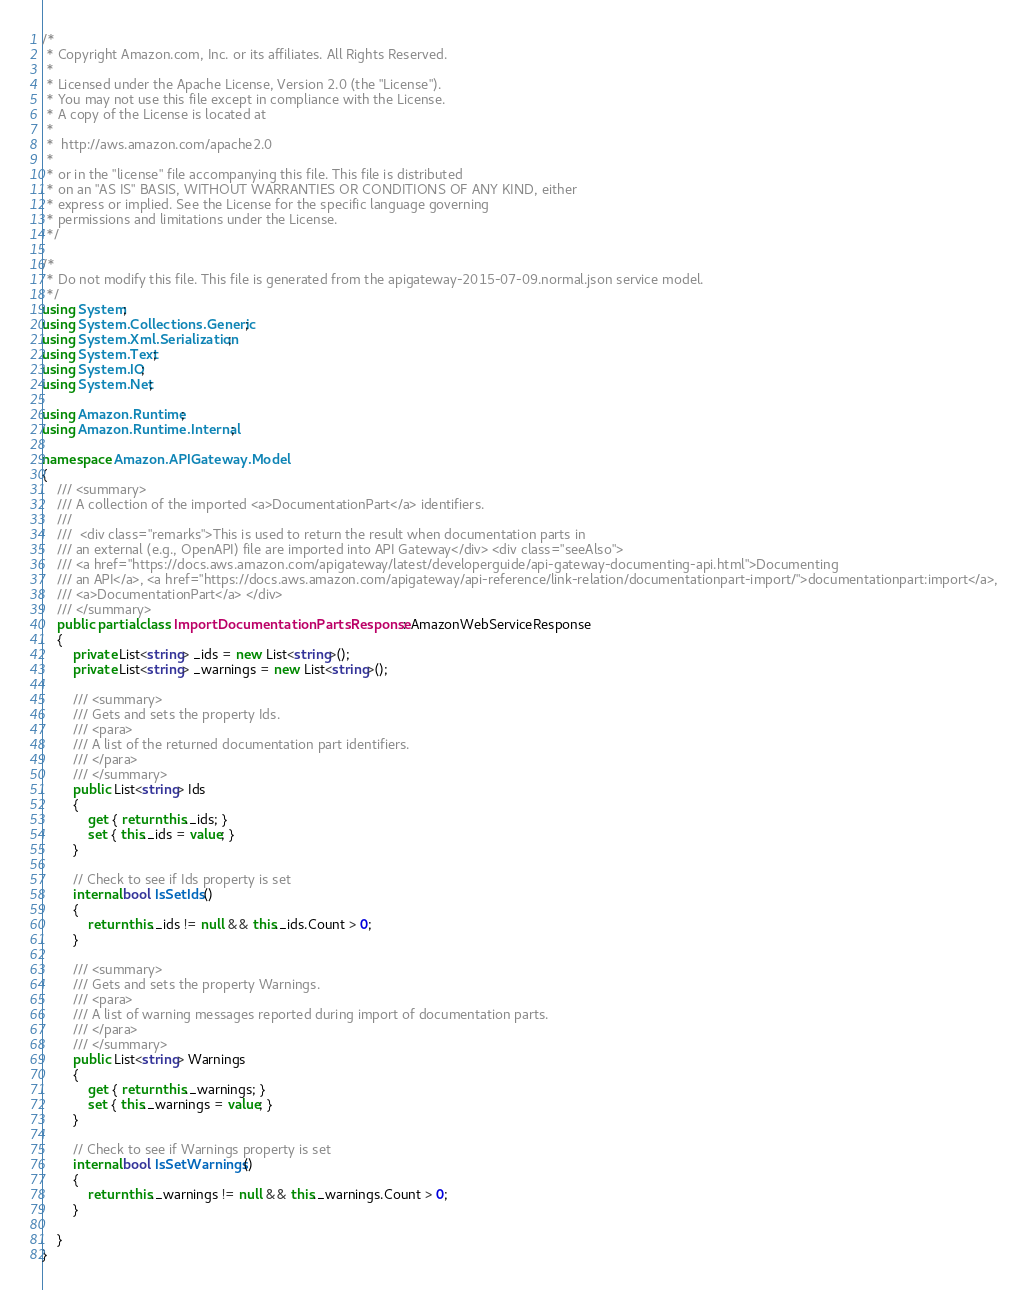Convert code to text. <code><loc_0><loc_0><loc_500><loc_500><_C#_>/*
 * Copyright Amazon.com, Inc. or its affiliates. All Rights Reserved.
 * 
 * Licensed under the Apache License, Version 2.0 (the "License").
 * You may not use this file except in compliance with the License.
 * A copy of the License is located at
 * 
 *  http://aws.amazon.com/apache2.0
 * 
 * or in the "license" file accompanying this file. This file is distributed
 * on an "AS IS" BASIS, WITHOUT WARRANTIES OR CONDITIONS OF ANY KIND, either
 * express or implied. See the License for the specific language governing
 * permissions and limitations under the License.
 */

/*
 * Do not modify this file. This file is generated from the apigateway-2015-07-09.normal.json service model.
 */
using System;
using System.Collections.Generic;
using System.Xml.Serialization;
using System.Text;
using System.IO;
using System.Net;

using Amazon.Runtime;
using Amazon.Runtime.Internal;

namespace Amazon.APIGateway.Model
{
    /// <summary>
    /// A collection of the imported <a>DocumentationPart</a> identifiers.
    /// 
    ///  <div class="remarks">This is used to return the result when documentation parts in
    /// an external (e.g., OpenAPI) file are imported into API Gateway</div> <div class="seeAlso">
    /// <a href="https://docs.aws.amazon.com/apigateway/latest/developerguide/api-gateway-documenting-api.html">Documenting
    /// an API</a>, <a href="https://docs.aws.amazon.com/apigateway/api-reference/link-relation/documentationpart-import/">documentationpart:import</a>,
    /// <a>DocumentationPart</a> </div>
    /// </summary>
    public partial class ImportDocumentationPartsResponse : AmazonWebServiceResponse
    {
        private List<string> _ids = new List<string>();
        private List<string> _warnings = new List<string>();

        /// <summary>
        /// Gets and sets the property Ids. 
        /// <para>
        /// A list of the returned documentation part identifiers.
        /// </para>
        /// </summary>
        public List<string> Ids
        {
            get { return this._ids; }
            set { this._ids = value; }
        }

        // Check to see if Ids property is set
        internal bool IsSetIds()
        {
            return this._ids != null && this._ids.Count > 0; 
        }

        /// <summary>
        /// Gets and sets the property Warnings. 
        /// <para>
        /// A list of warning messages reported during import of documentation parts.
        /// </para>
        /// </summary>
        public List<string> Warnings
        {
            get { return this._warnings; }
            set { this._warnings = value; }
        }

        // Check to see if Warnings property is set
        internal bool IsSetWarnings()
        {
            return this._warnings != null && this._warnings.Count > 0; 
        }

    }
}</code> 